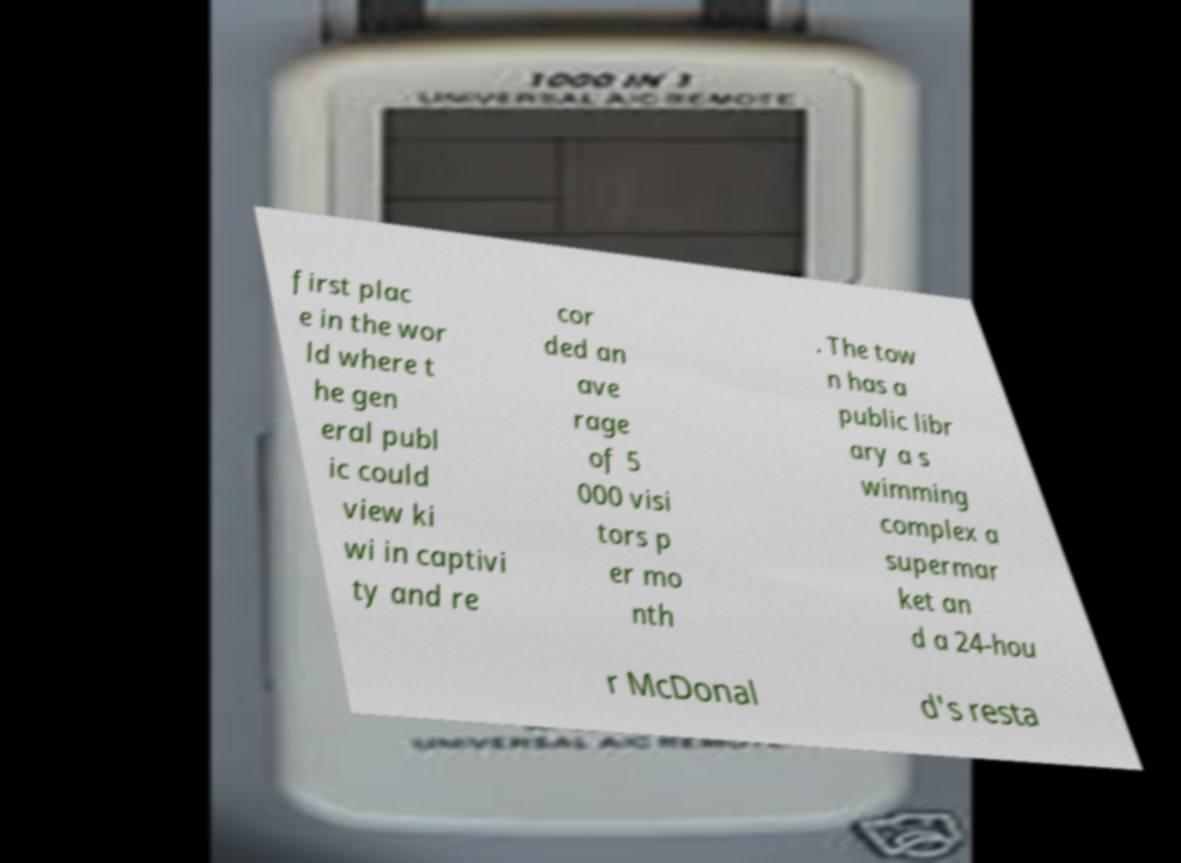Please read and relay the text visible in this image. What does it say? first plac e in the wor ld where t he gen eral publ ic could view ki wi in captivi ty and re cor ded an ave rage of 5 000 visi tors p er mo nth . The tow n has a public libr ary a s wimming complex a supermar ket an d a 24-hou r McDonal d's resta 